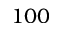<formula> <loc_0><loc_0><loc_500><loc_500>1 0 0</formula> 